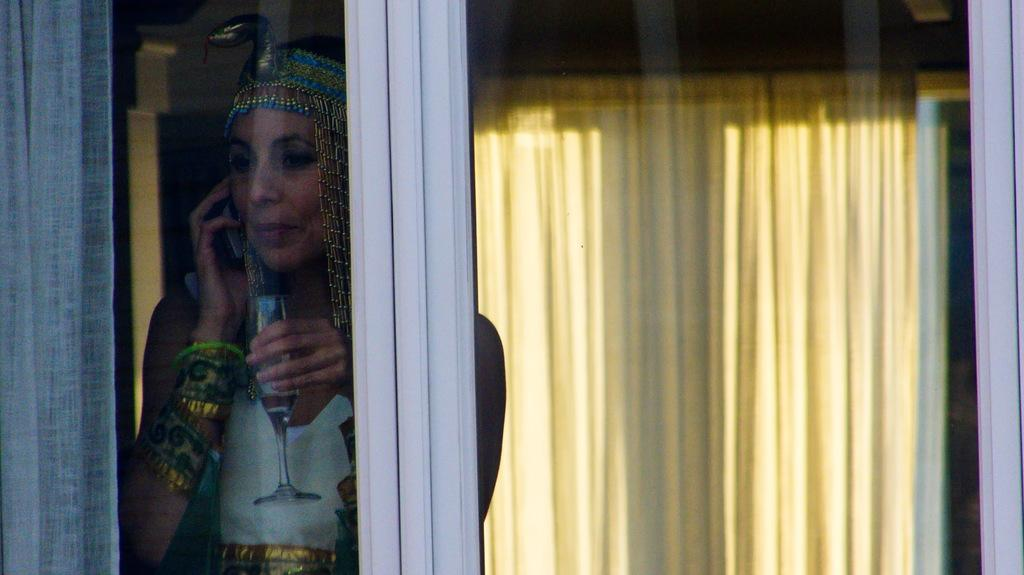What object is visible in the image that can hold a liquid? There is a glass in the image that can hold a liquid. What type of window treatment is present in the image? There is a curtain in the image. What is the woman in the image holding? The woman is holding a glass and a mobile in the image. Can the woman be seen through any object in the image? Yes, the woman is visible through the glass in the image. What can be seen in the background of the image? There is a curtain visible in the background of the image. What type of flower is growing in the image? There is no flower present in the image. What type of agricultural equipment can be seen in the image? There is no agricultural equipment, such as a plough, present in the image. 